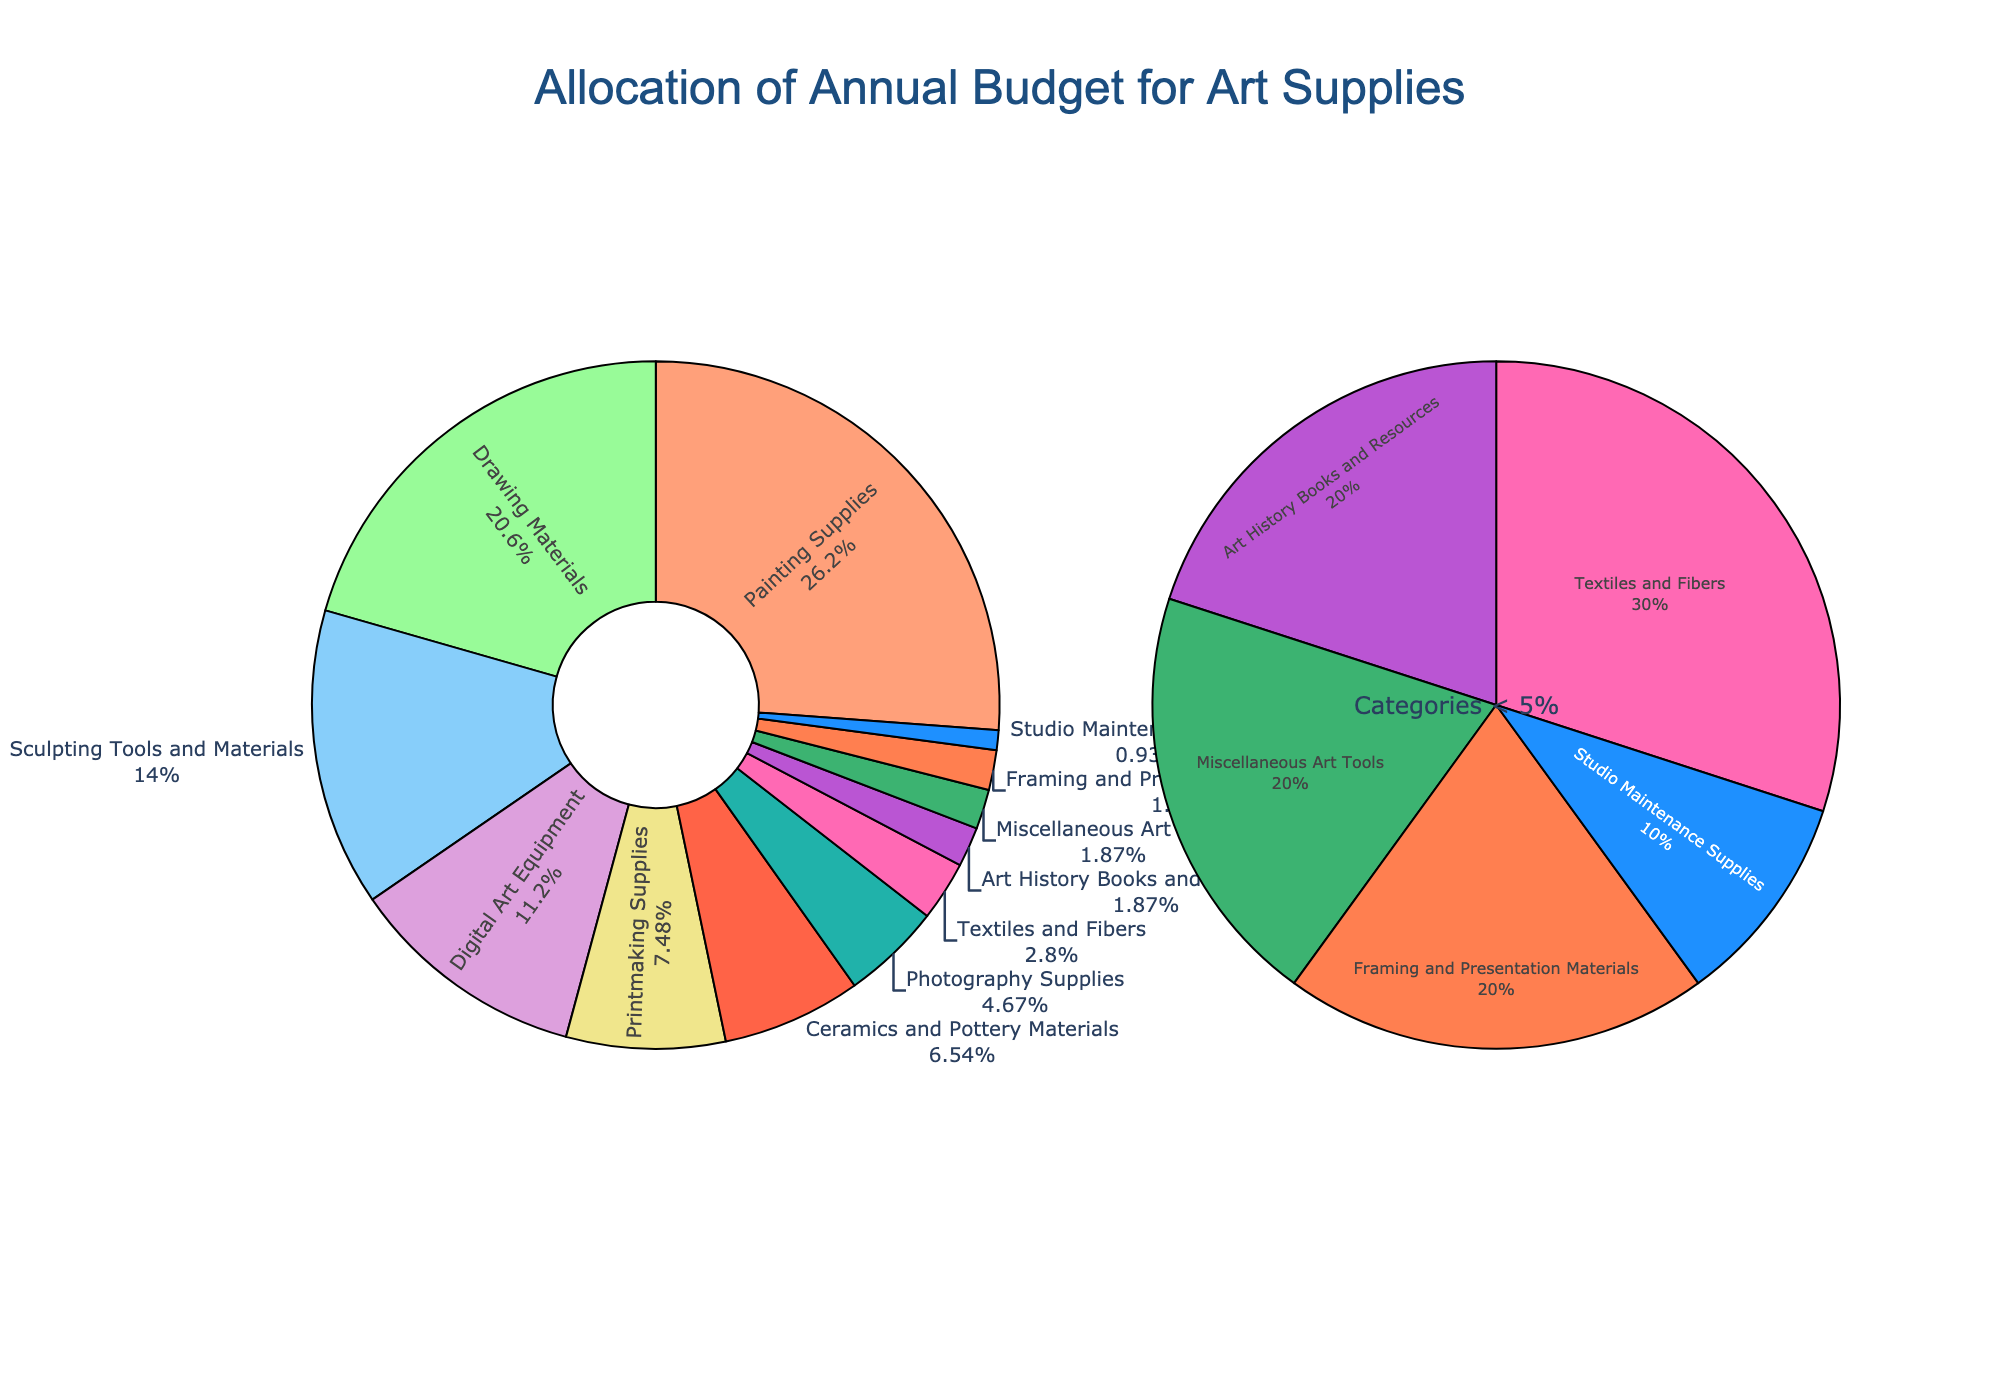Which category has the highest percentage allocation in the budget? By looking at the pie chart, the category with the largest slice represents the highest percentage. In this case, it is "Painting Supplies."
Answer: Painting Supplies What is the total percentage allocated to Painting Supplies and Drawing Materials combined? To find the combined percentage, add the individual percentages of "Painting Supplies" and "Drawing Materials." This is 28% + 22% = 50%.
Answer: 50% Which category has a smaller budget allocation, Digital Art Equipment or Sculpting Tools and Materials? By comparing the sizes of the slices for "Digital Art Equipment" and "Sculpting Tools and Materials," it is evident that "Digital Art Equipment" has a smaller budget allocation with 12% compared to 15%.
Answer: Digital Art Equipment Are there more categories with allocations below 5% or more than 20%? Count the number of categories below 5%: Photography Supplies, Textiles and Fibers, Art History Books and Resources, Miscellaneous Art Tools, Framing and Presentation Materials, Studio Maintenance Supplies (6 categories). Compare to the number of categories above 20%: Painting Supplies and Drawing Materials (2 categories). Thus, there are more categories below 5%.
Answer: Below 5% What is the percentage difference between the highest and lowest budget allocations? Identify the highest allocation (Painting Supplies, 28%) and the lowest (Studio Maintenance Supplies, 1%). The difference is 28% - 1% = 27%.
Answer: 27% How do the combined budget allocations of categories less than 5% compare to the allocation for Drawing Materials? Add the percentages of categories less than 5% which are: Photography Supplies (5%), Textiles and Fibers (3%), Art History Books and Resources (2%), Miscellaneous Art Tools (2%), Framing and Presentation Materials (2%), and Studio Maintenance Supplies (1%). The total is 5% + 3% + 2% + 2% + 2% + 1% = 15%. Drawing Materials alone is allocated 22%. Thus, the combined categories under 5% are less than Drawing Materials.
Answer: Less than Drawing Materials Which visual attribute indicates the smallest budget allocation? The slice of the pie chart that is the smallest in size and located near the periphery with the smallest annotation text represents the category with the smallest allocation. This attribute indicates "Studio Maintenance Supplies" with 1%.
Answer: Studio Maintenance Supplies If the budget for Ceramics and Pottery Materials were doubled, what percentage of the total would it then represent? The current allocation for Ceramics and Pottery Materials is 7%. If doubled, it becomes 7% * 2 = 14%.
Answer: 14% Which category has an allocation closest to 10%? By looking at the pie slices and their percentage labels, the category "Digital Art Equipment" with 12% is the closest to 10%.
Answer: Digital Art Equipment What is the combined budget allocation for categories involved directly in producing physical art (Painting Supplies, Drawing Materials, Sculpting Tools and Materials, Printmaking Supplies, Ceramics and Pottery Materials)? Sum the percentages for Painting Supplies (28%), Drawing Materials (22%), Sculpting Tools and Materials (15%), Printmaking Supplies (8%), and Ceramics and Pottery Materials (7%). The total is 28% + 22% + 15% + 8% + 7% = 80%.
Answer: 80% 